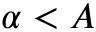Convert formula to latex. <formula><loc_0><loc_0><loc_500><loc_500>\alpha < A</formula> 